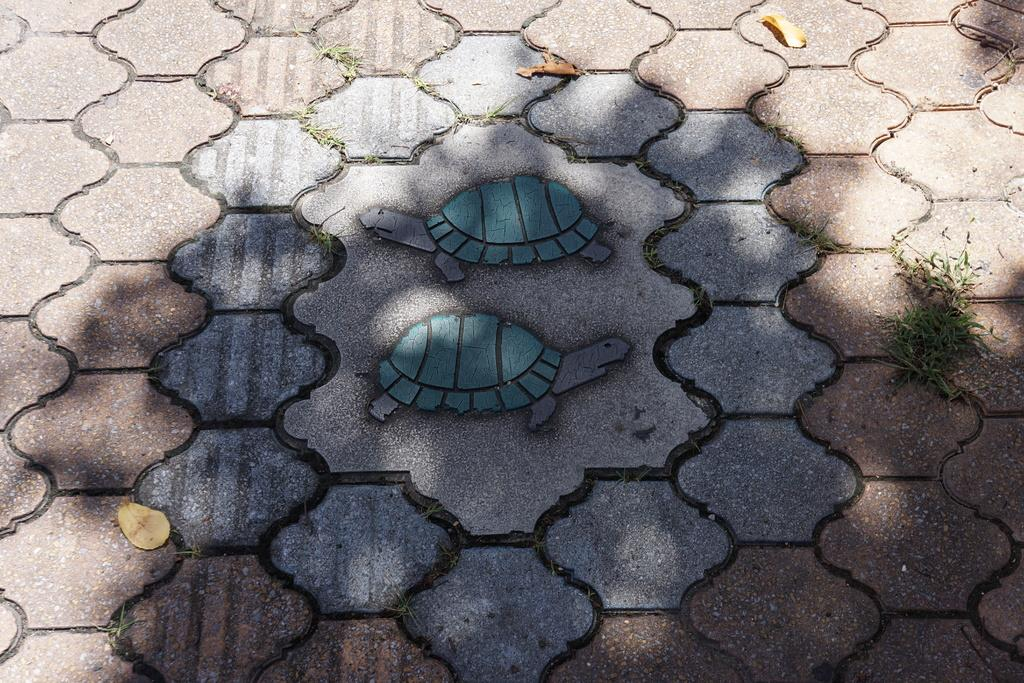What type of surface is visible in the image? There is a floor visible in the image. What type of animals are depicted in the pictures in the image? There are two pictures of tortoises in the image. What type of plant material is present in the image? There are dry leaves in the image. What type of vegetation is visible in the image? There is grass visible in the image. What type of fiction is being developed in the image? There is no reference to fiction or development in the image; it features a floor, pictures of tortoises, dry leaves, and grass. What type of sheet is covering the tortoises in the image? There are no tortoises being covered by a sheet in the image; the tortoises are depicted in pictures. 